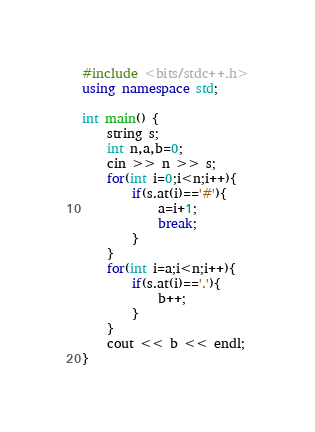<code> <loc_0><loc_0><loc_500><loc_500><_C++_>#include <bits/stdc++.h>
using namespace std;

int main() {
    string s;
    int n,a,b=0;
    cin >> n >> s;
    for(int i=0;i<n;i++){
        if(s.at(i)=='#'){
            a=i+1;
            break;
        }
    }
    for(int i=a;i<n;i++){
        if(s.at(i)=='.'){
            b++;
        }
    }
    cout << b << endl;
}
</code> 